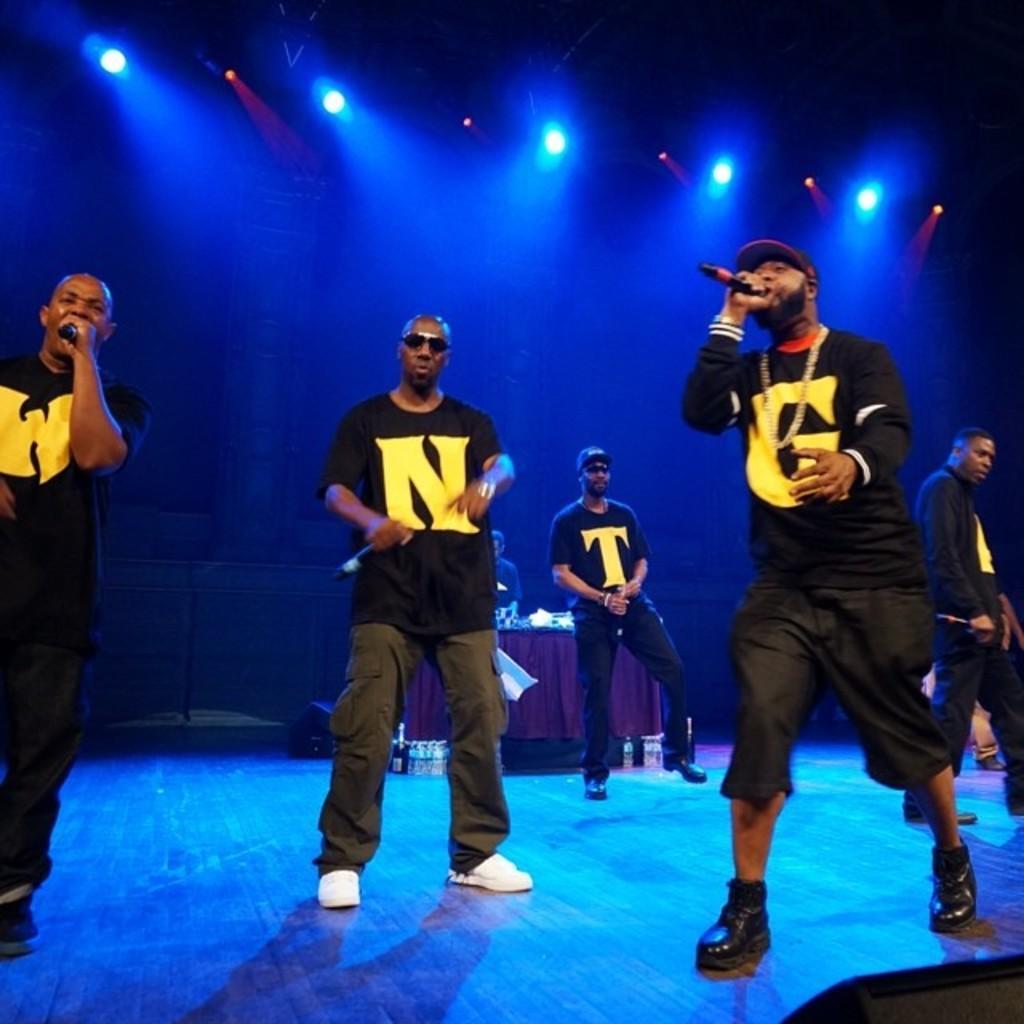Can you describe this image briefly? In the center of the image we can see a few people are standing and they are holding microphones and they are in black color t shirts. Among them, we can see two persons are wearing caps and two persons are wearing glasses. In the background, we can see the lights, one table, one cloth, water bottles, one person standing and a few other objects. 